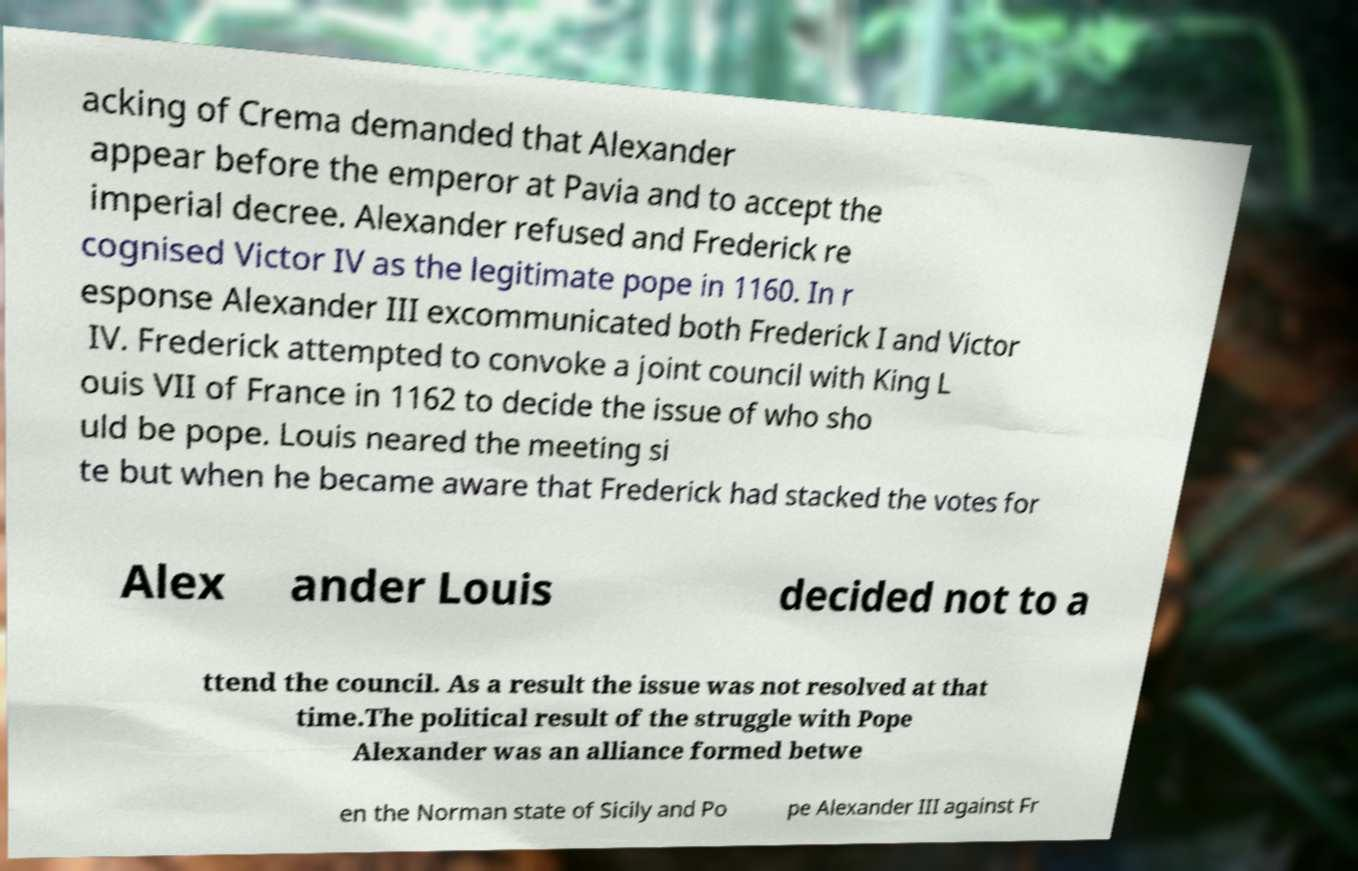For documentation purposes, I need the text within this image transcribed. Could you provide that? acking of Crema demanded that Alexander appear before the emperor at Pavia and to accept the imperial decree. Alexander refused and Frederick re cognised Victor IV as the legitimate pope in 1160. In r esponse Alexander III excommunicated both Frederick I and Victor IV. Frederick attempted to convoke a joint council with King L ouis VII of France in 1162 to decide the issue of who sho uld be pope. Louis neared the meeting si te but when he became aware that Frederick had stacked the votes for Alex ander Louis decided not to a ttend the council. As a result the issue was not resolved at that time.The political result of the struggle with Pope Alexander was an alliance formed betwe en the Norman state of Sicily and Po pe Alexander III against Fr 